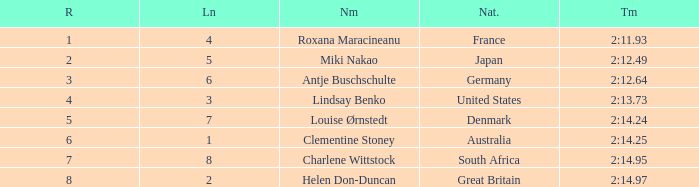What is the average Rank for a lane smaller than 3 with a nationality of Australia? 6.0. 